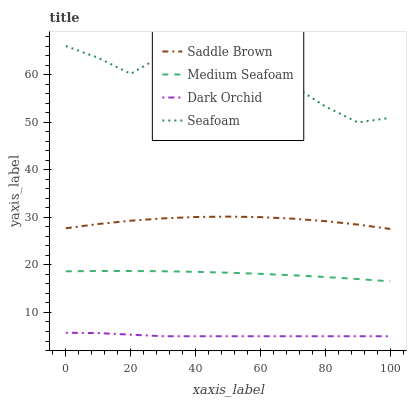Does Saddle Brown have the minimum area under the curve?
Answer yes or no. No. Does Saddle Brown have the maximum area under the curve?
Answer yes or no. No. Is Saddle Brown the smoothest?
Answer yes or no. No. Is Saddle Brown the roughest?
Answer yes or no. No. Does Saddle Brown have the lowest value?
Answer yes or no. No. Does Saddle Brown have the highest value?
Answer yes or no. No. Is Dark Orchid less than Seafoam?
Answer yes or no. Yes. Is Saddle Brown greater than Dark Orchid?
Answer yes or no. Yes. Does Dark Orchid intersect Seafoam?
Answer yes or no. No. 